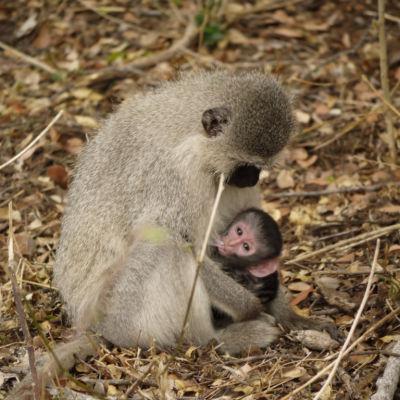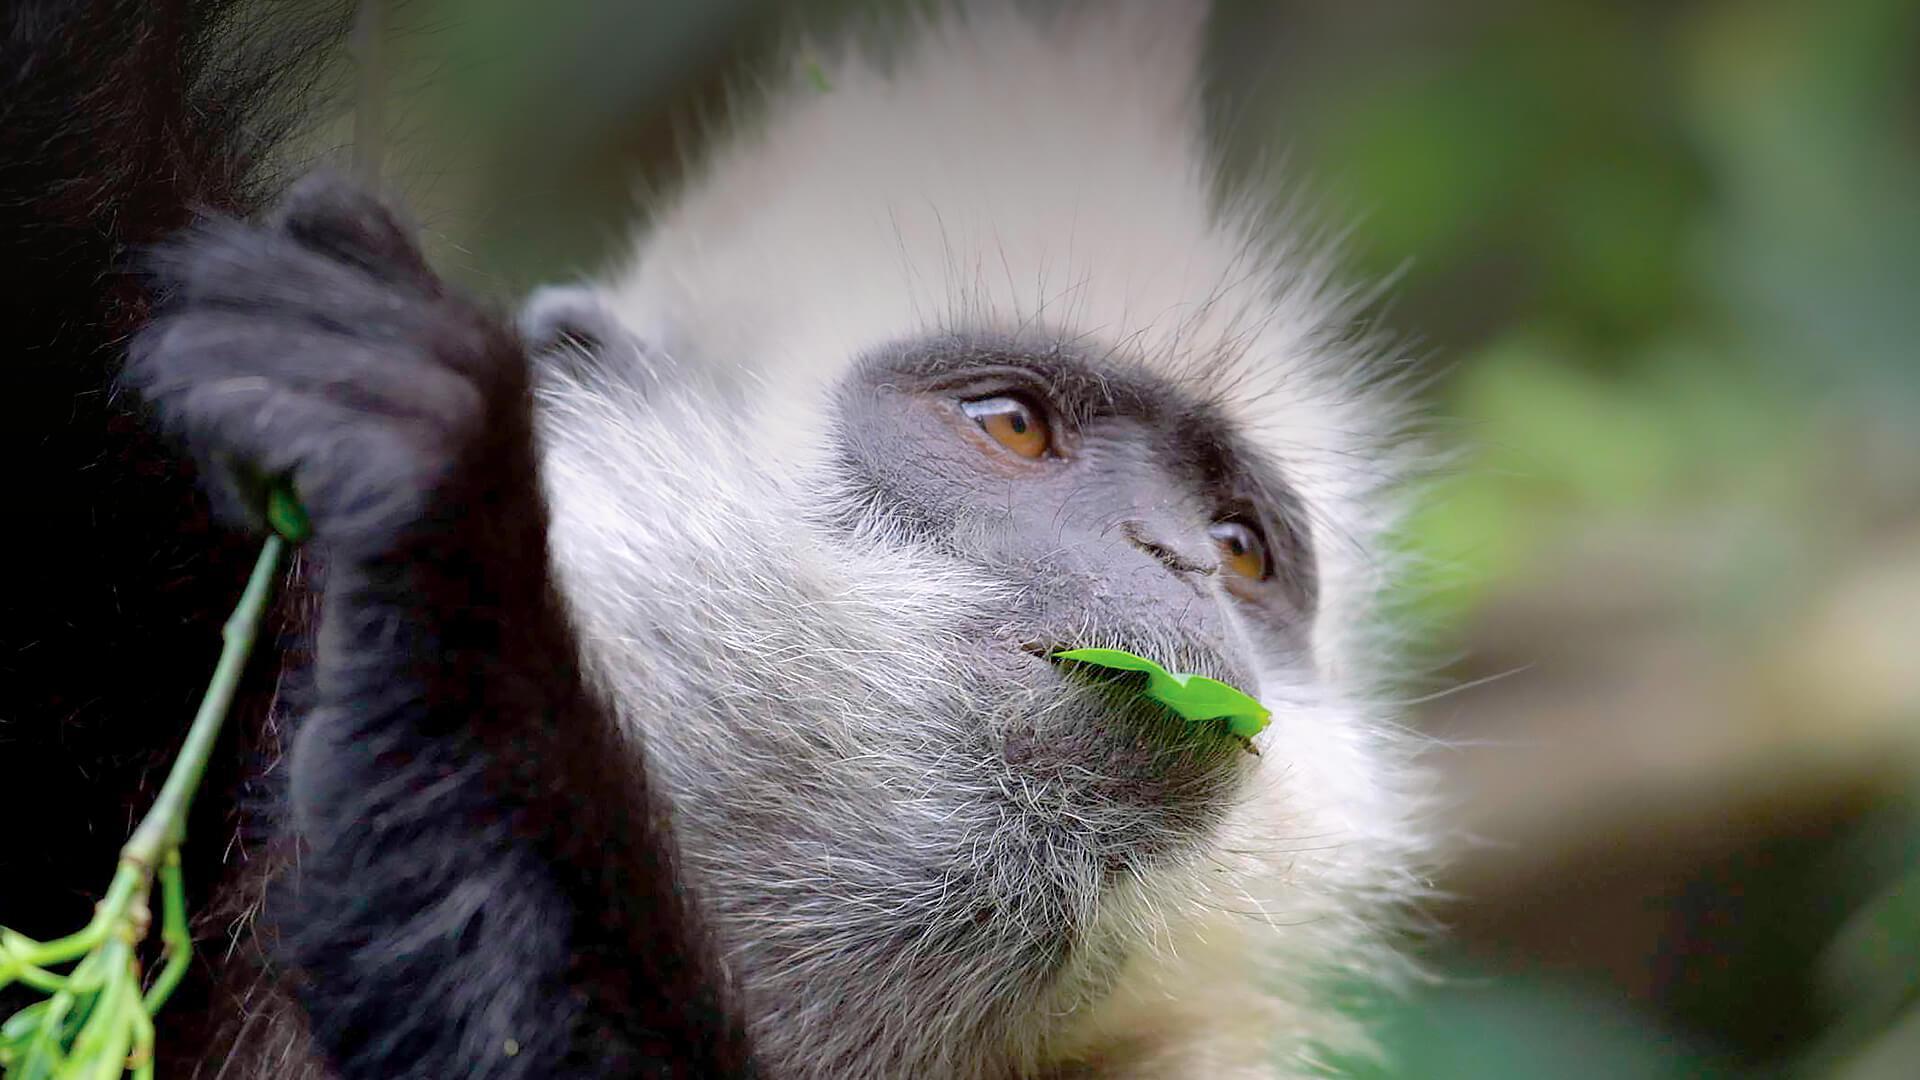The first image is the image on the left, the second image is the image on the right. Examine the images to the left and right. Is the description "The right image contains at least two baboons." accurate? Answer yes or no. No. The first image is the image on the left, the second image is the image on the right. Evaluate the accuracy of this statement regarding the images: "There are at most three monkeys". Is it true? Answer yes or no. Yes. The first image is the image on the left, the second image is the image on the right. Analyze the images presented: Is the assertion "There are no more than three monkeys total per pair of images." valid? Answer yes or no. Yes. The first image is the image on the left, the second image is the image on the right. For the images displayed, is the sentence "A pink-faced baby baboo is held to the chest of its rightward-turned mother in one image." factually correct? Answer yes or no. Yes. 